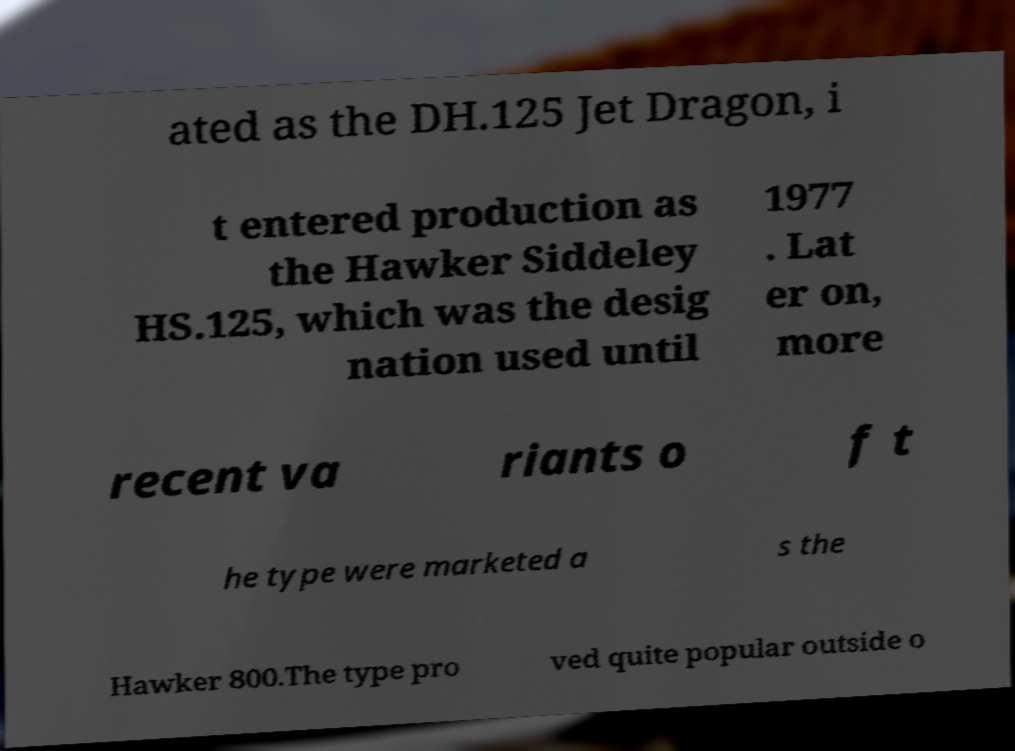Can you read and provide the text displayed in the image?This photo seems to have some interesting text. Can you extract and type it out for me? ated as the DH.125 Jet Dragon, i t entered production as the Hawker Siddeley HS.125, which was the desig nation used until 1977 . Lat er on, more recent va riants o f t he type were marketed a s the Hawker 800.The type pro ved quite popular outside o 